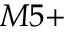<formula> <loc_0><loc_0><loc_500><loc_500>M 5 +</formula> 